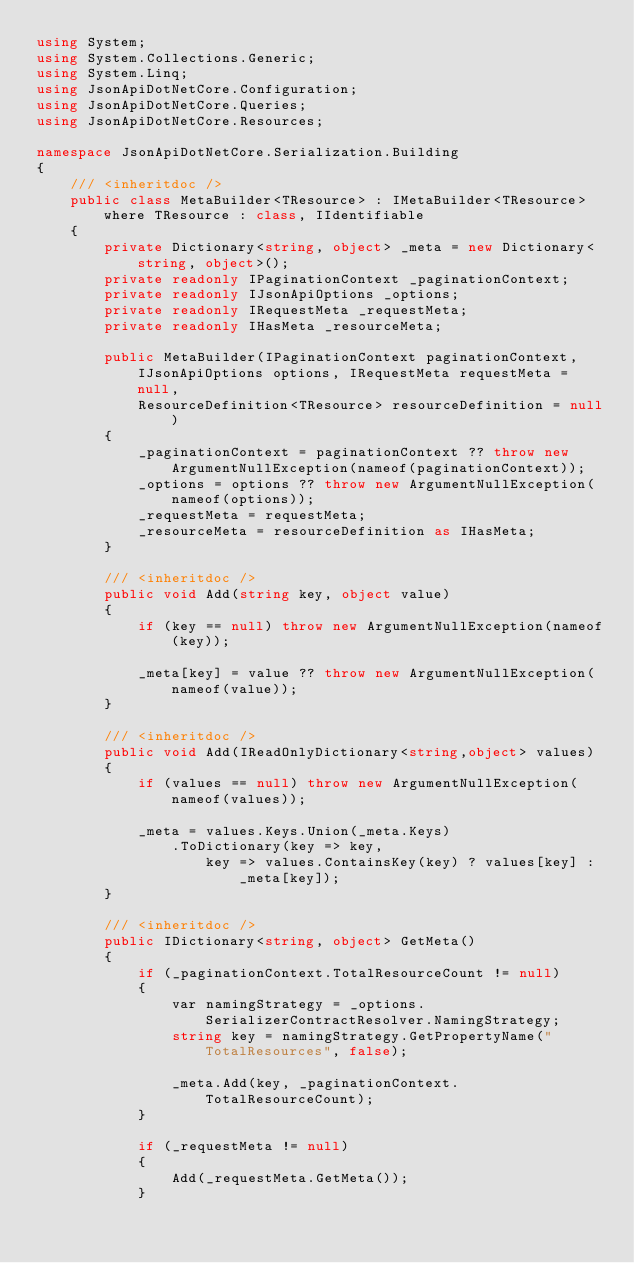<code> <loc_0><loc_0><loc_500><loc_500><_C#_>using System;
using System.Collections.Generic;
using System.Linq;
using JsonApiDotNetCore.Configuration;
using JsonApiDotNetCore.Queries;
using JsonApiDotNetCore.Resources;

namespace JsonApiDotNetCore.Serialization.Building
{
    /// <inheritdoc />
    public class MetaBuilder<TResource> : IMetaBuilder<TResource> where TResource : class, IIdentifiable
    {
        private Dictionary<string, object> _meta = new Dictionary<string, object>();
        private readonly IPaginationContext _paginationContext;
        private readonly IJsonApiOptions _options;
        private readonly IRequestMeta _requestMeta;
        private readonly IHasMeta _resourceMeta;

        public MetaBuilder(IPaginationContext paginationContext, IJsonApiOptions options, IRequestMeta requestMeta = null,
            ResourceDefinition<TResource> resourceDefinition = null)
        {
            _paginationContext = paginationContext ?? throw new ArgumentNullException(nameof(paginationContext));
            _options = options ?? throw new ArgumentNullException(nameof(options));
            _requestMeta = requestMeta;
            _resourceMeta = resourceDefinition as IHasMeta;
        }

        /// <inheritdoc />
        public void Add(string key, object value)
        {
            if (key == null) throw new ArgumentNullException(nameof(key));

            _meta[key] = value ?? throw new ArgumentNullException(nameof(value));
        }

        /// <inheritdoc />
        public void Add(IReadOnlyDictionary<string,object> values)
        {
            if (values == null) throw new ArgumentNullException(nameof(values));

            _meta = values.Keys.Union(_meta.Keys)
                .ToDictionary(key => key, 
                    key => values.ContainsKey(key) ? values[key] : _meta[key]);
        }

        /// <inheritdoc />
        public IDictionary<string, object> GetMeta()
        {
            if (_paginationContext.TotalResourceCount != null)
            {
                var namingStrategy = _options.SerializerContractResolver.NamingStrategy;
                string key = namingStrategy.GetPropertyName("TotalResources", false);

                _meta.Add(key, _paginationContext.TotalResourceCount);
            }

            if (_requestMeta != null)
            {
                Add(_requestMeta.GetMeta());
            }
</code> 